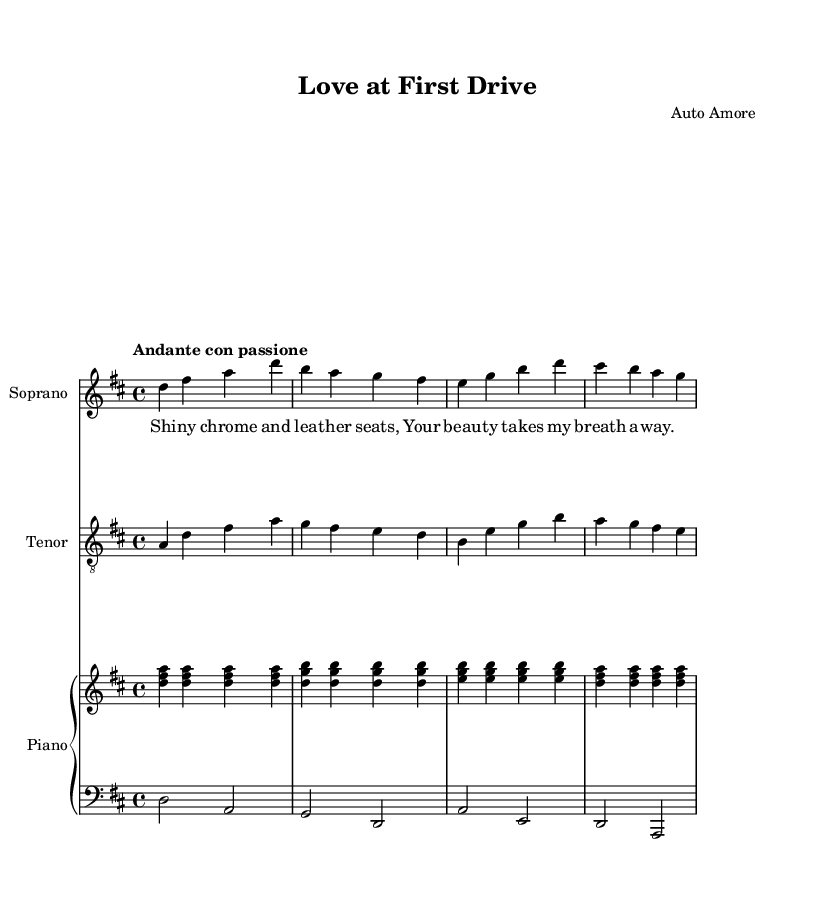What is the key signature of this music? The key signature is D major, indicated by two sharps (F# and C#) next to the treble and bass staff.
Answer: D major What is the time signature of this music? The time signature is 4/4, shown at the beginning of the piece, indicating four beats per measure.
Answer: 4/4 What is the tempo marking for this piece? The tempo marking is "Andante con passione," which suggests a moderate pace with passion.
Answer: Andante con passione How many measures are in the soprano part? The soprano part consists of eight measures, indicated by the notation in a two-bar pattern repeated structure.
Answer: Eight measures What genre does this duet belong to? This duet belongs to Opera, as suggested by the vocal arrangements and the structure of the piece that features singing accompanied by piano.
Answer: Opera What type of relationship does the lyric convey? The lyric conveys a romantic relationship characterized by admiration and attraction, reflecting the theme of love at first sight.
Answer: Romantic admiration Which vocal parts are featured in this duet? The duet features soprano and tenor vocal parts, indicated in the score with labels for each staff.
Answer: Soprano and tenor 